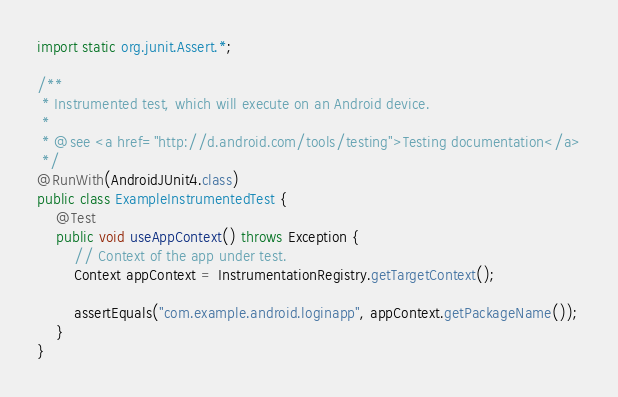<code> <loc_0><loc_0><loc_500><loc_500><_Java_>import static org.junit.Assert.*;

/**
 * Instrumented test, which will execute on an Android device.
 *
 * @see <a href="http://d.android.com/tools/testing">Testing documentation</a>
 */
@RunWith(AndroidJUnit4.class)
public class ExampleInstrumentedTest {
    @Test
    public void useAppContext() throws Exception {
        // Context of the app under test.
        Context appContext = InstrumentationRegistry.getTargetContext();

        assertEquals("com.example.android.loginapp", appContext.getPackageName());
    }
}
</code> 